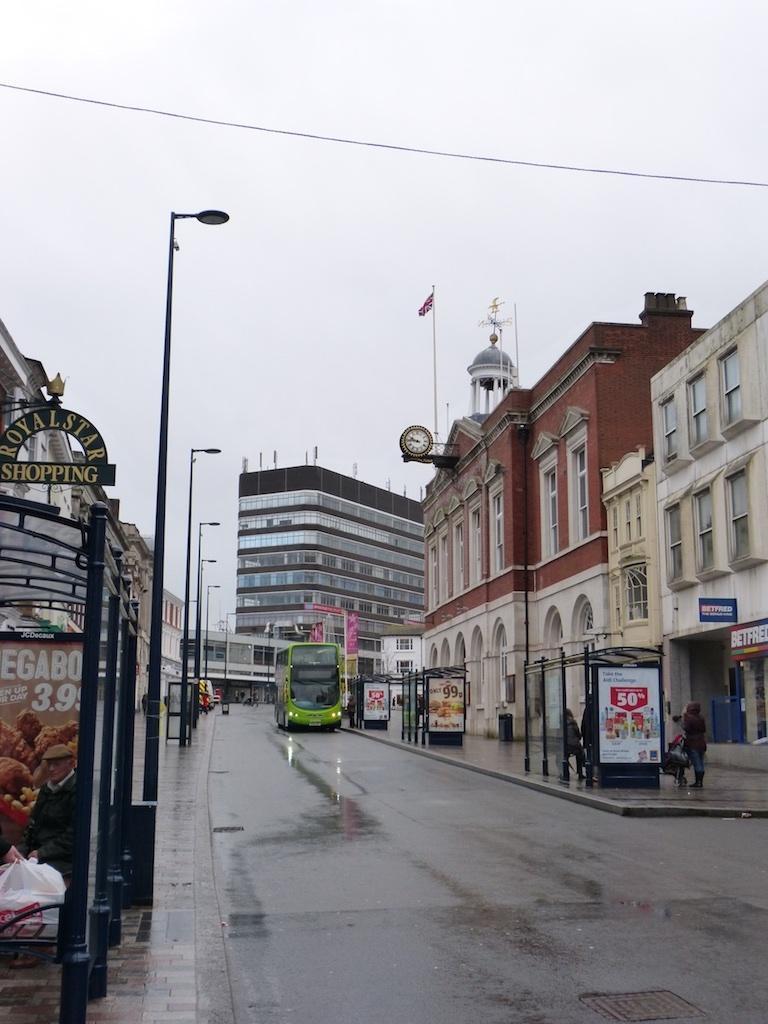In one or two sentences, can you explain what this image depicts? In this picture I can see buildings and few pole lights and I can see a flag pole on the building and a bus moving on the road and few people standing and I can see board with some text and a cloudy sky. 